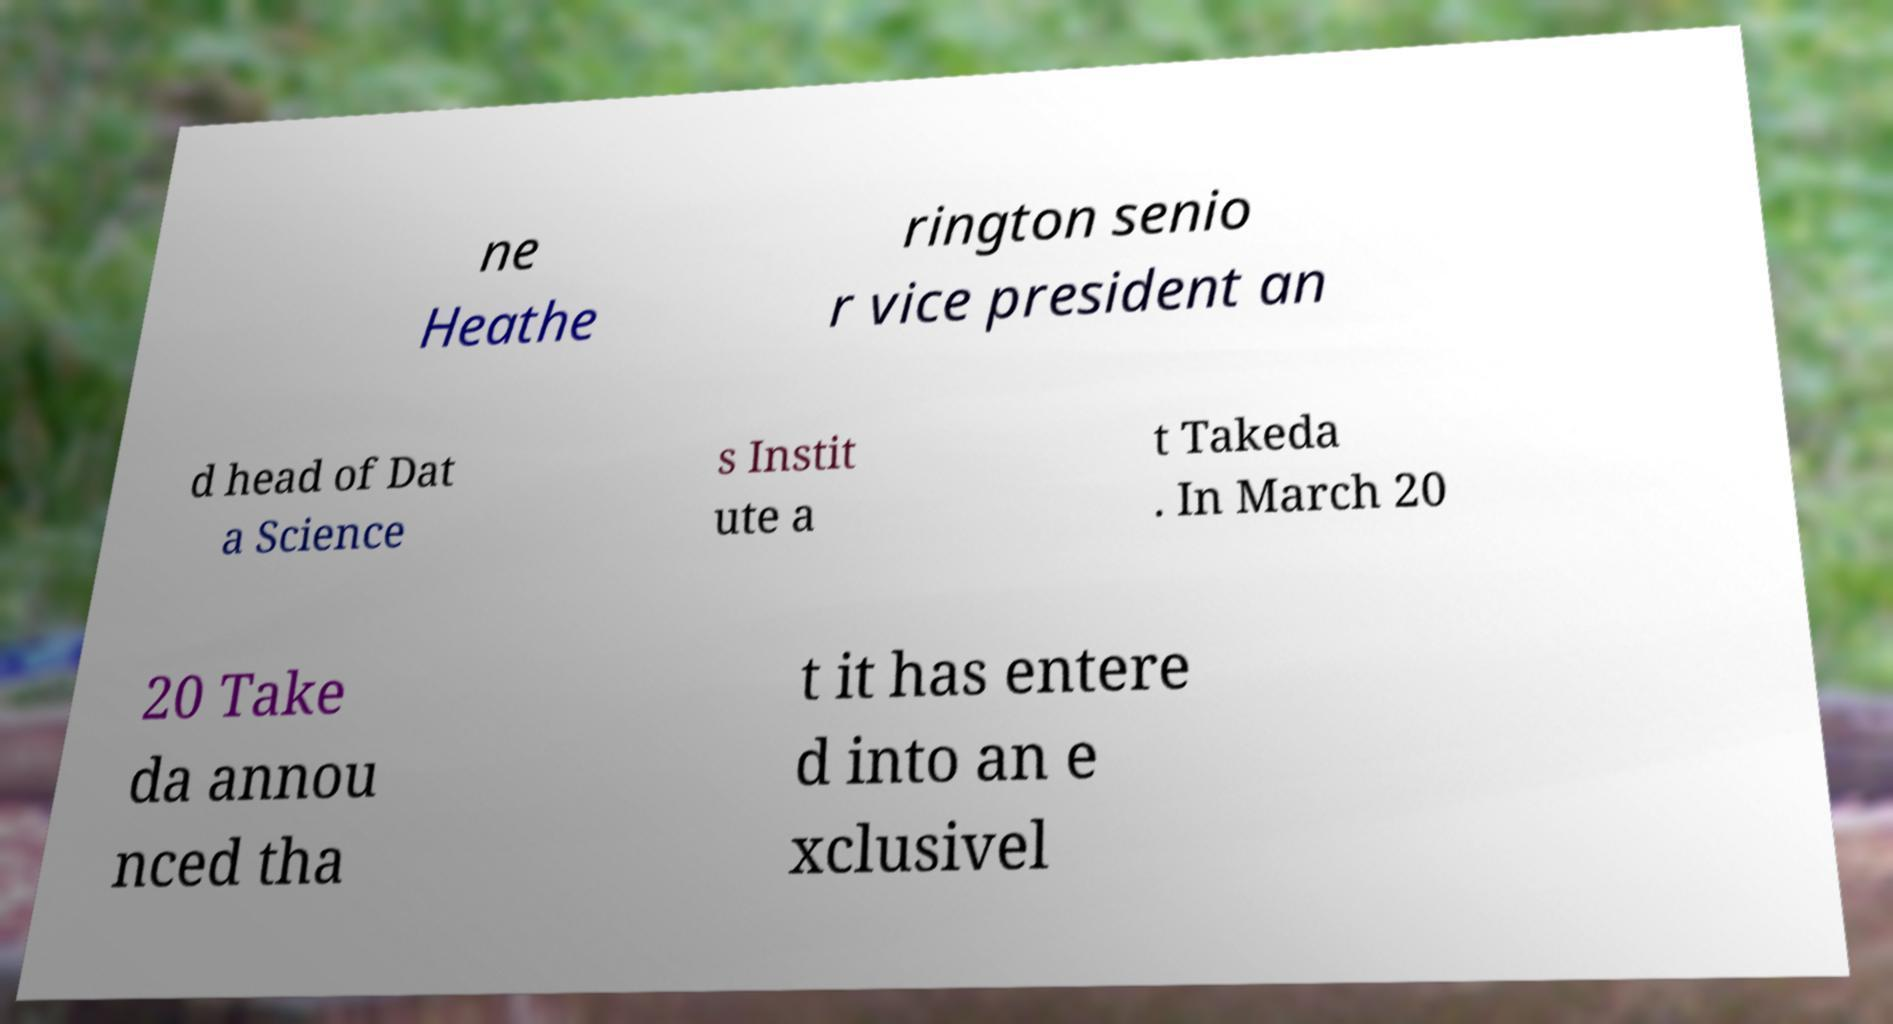What messages or text are displayed in this image? I need them in a readable, typed format. ne Heathe rington senio r vice president an d head of Dat a Science s Instit ute a t Takeda . In March 20 20 Take da annou nced tha t it has entere d into an e xclusivel 